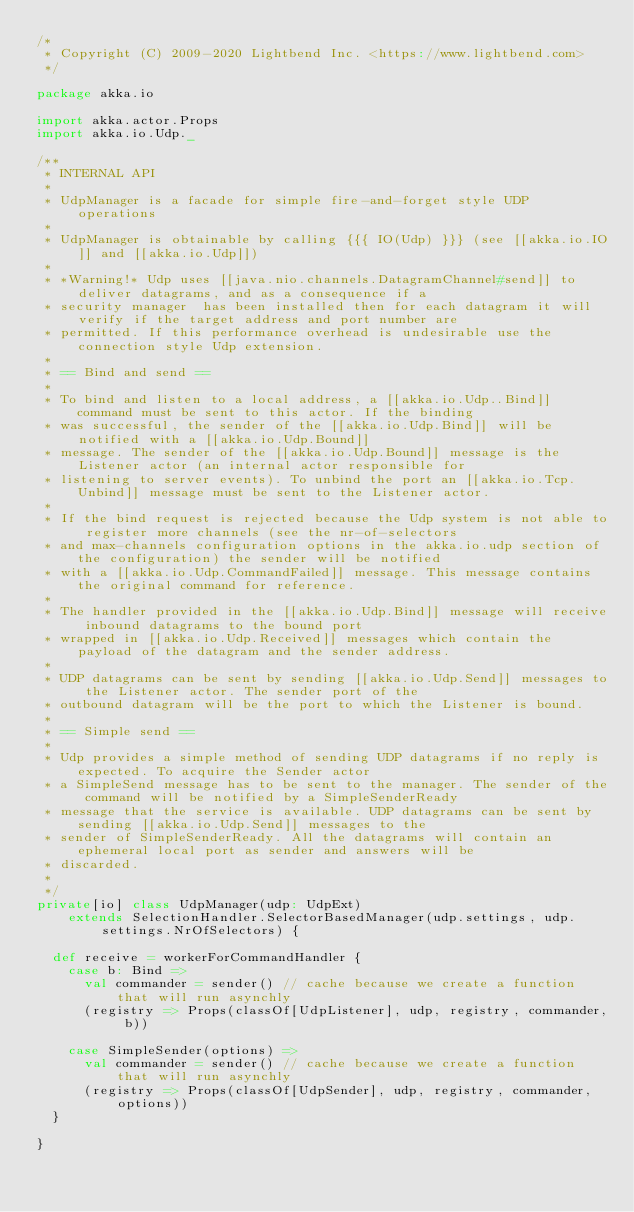<code> <loc_0><loc_0><loc_500><loc_500><_Scala_>/*
 * Copyright (C) 2009-2020 Lightbend Inc. <https://www.lightbend.com>
 */

package akka.io

import akka.actor.Props
import akka.io.Udp._

/**
 * INTERNAL API
 *
 * UdpManager is a facade for simple fire-and-forget style UDP operations
 *
 * UdpManager is obtainable by calling {{{ IO(Udp) }}} (see [[akka.io.IO]] and [[akka.io.Udp]])
 *
 * *Warning!* Udp uses [[java.nio.channels.DatagramChannel#send]] to deliver datagrams, and as a consequence if a
 * security manager  has been installed then for each datagram it will verify if the target address and port number are
 * permitted. If this performance overhead is undesirable use the connection style Udp extension.
 *
 * == Bind and send ==
 *
 * To bind and listen to a local address, a [[akka.io.Udp..Bind]] command must be sent to this actor. If the binding
 * was successful, the sender of the [[akka.io.Udp.Bind]] will be notified with a [[akka.io.Udp.Bound]]
 * message. The sender of the [[akka.io.Udp.Bound]] message is the Listener actor (an internal actor responsible for
 * listening to server events). To unbind the port an [[akka.io.Tcp.Unbind]] message must be sent to the Listener actor.
 *
 * If the bind request is rejected because the Udp system is not able to register more channels (see the nr-of-selectors
 * and max-channels configuration options in the akka.io.udp section of the configuration) the sender will be notified
 * with a [[akka.io.Udp.CommandFailed]] message. This message contains the original command for reference.
 *
 * The handler provided in the [[akka.io.Udp.Bind]] message will receive inbound datagrams to the bound port
 * wrapped in [[akka.io.Udp.Received]] messages which contain the payload of the datagram and the sender address.
 *
 * UDP datagrams can be sent by sending [[akka.io.Udp.Send]] messages to the Listener actor. The sender port of the
 * outbound datagram will be the port to which the Listener is bound.
 *
 * == Simple send ==
 *
 * Udp provides a simple method of sending UDP datagrams if no reply is expected. To acquire the Sender actor
 * a SimpleSend message has to be sent to the manager. The sender of the command will be notified by a SimpleSenderReady
 * message that the service is available. UDP datagrams can be sent by sending [[akka.io.Udp.Send]] messages to the
 * sender of SimpleSenderReady. All the datagrams will contain an ephemeral local port as sender and answers will be
 * discarded.
 *
 */
private[io] class UdpManager(udp: UdpExt)
    extends SelectionHandler.SelectorBasedManager(udp.settings, udp.settings.NrOfSelectors) {

  def receive = workerForCommandHandler {
    case b: Bind =>
      val commander = sender() // cache because we create a function that will run asynchly
      (registry => Props(classOf[UdpListener], udp, registry, commander, b))

    case SimpleSender(options) =>
      val commander = sender() // cache because we create a function that will run asynchly
      (registry => Props(classOf[UdpSender], udp, registry, commander, options))
  }

}
</code> 